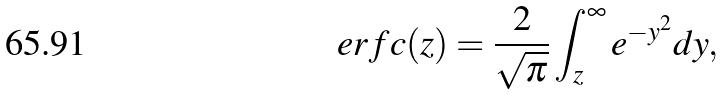<formula> <loc_0><loc_0><loc_500><loc_500>e r f c ( z ) = \frac { 2 } { \sqrt { \pi } } \int ^ { \infty } _ { z } e ^ { - y ^ { 2 } } d y ,</formula> 